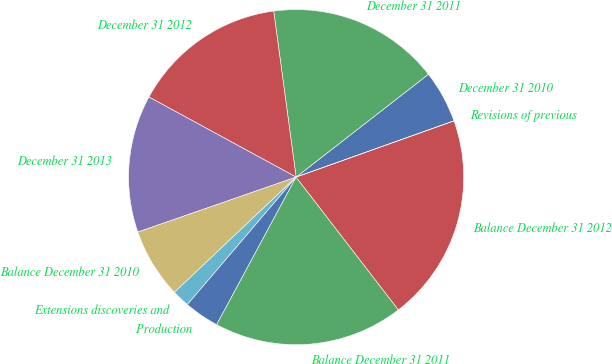Convert chart. <chart><loc_0><loc_0><loc_500><loc_500><pie_chart><fcel>December 31 2010<fcel>December 31 2011<fcel>December 31 2012<fcel>December 31 2013<fcel>Balance December 31 2010<fcel>Extensions discoveries and<fcel>Production<fcel>Balance December 31 2011<fcel>Balance December 31 2012<fcel>Revisions of previous<nl><fcel>5.07%<fcel>16.62%<fcel>14.93%<fcel>13.25%<fcel>6.75%<fcel>1.69%<fcel>3.38%<fcel>18.31%<fcel>20.0%<fcel>0.0%<nl></chart> 